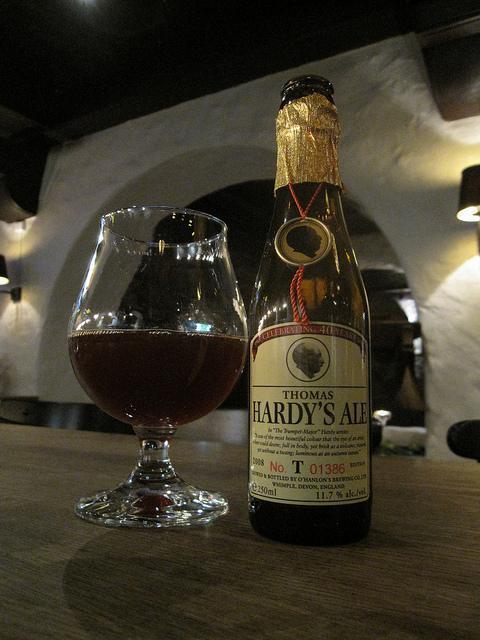What celebrity has a similar name to the name on the bottle?
Pick the correct solution from the four options below to address the question.
Options: Charlize theron, gaite jansen, tom hardy, cillian murphy. Tom hardy. 